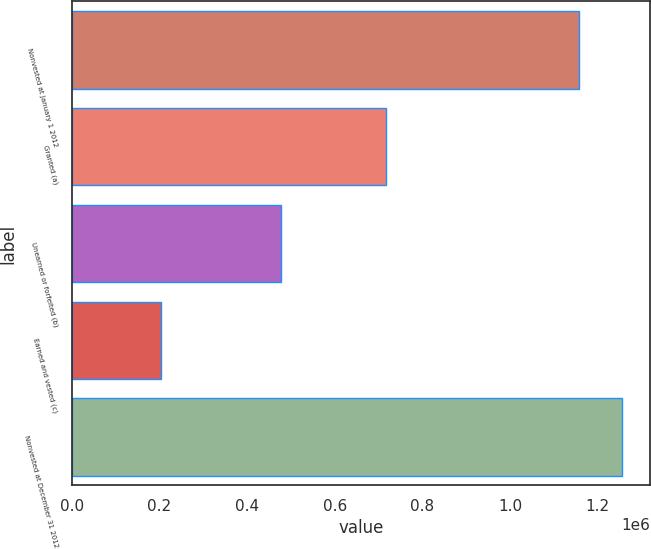Convert chart to OTSL. <chart><loc_0><loc_0><loc_500><loc_500><bar_chart><fcel>Nonvested at January 1 2012<fcel>Granted (a)<fcel>Unearned or forfeited (b)<fcel>Earned and vested (c)<fcel>Nonvested at December 31 2012<nl><fcel>1.15683e+06<fcel>717151<fcel>477928<fcel>203567<fcel>1.25572e+06<nl></chart> 